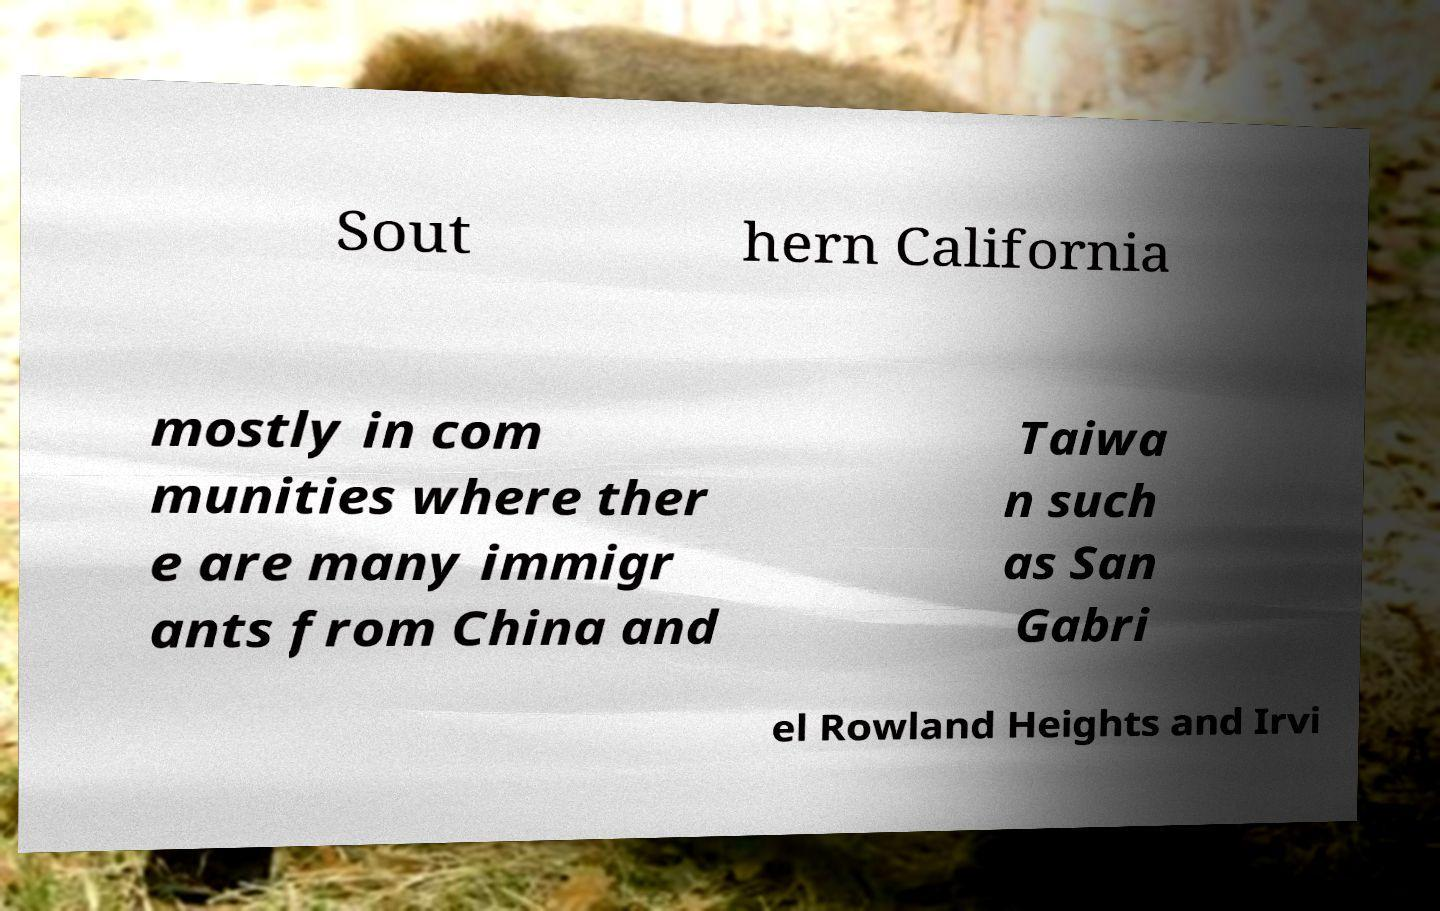Please identify and transcribe the text found in this image. Sout hern California mostly in com munities where ther e are many immigr ants from China and Taiwa n such as San Gabri el Rowland Heights and Irvi 